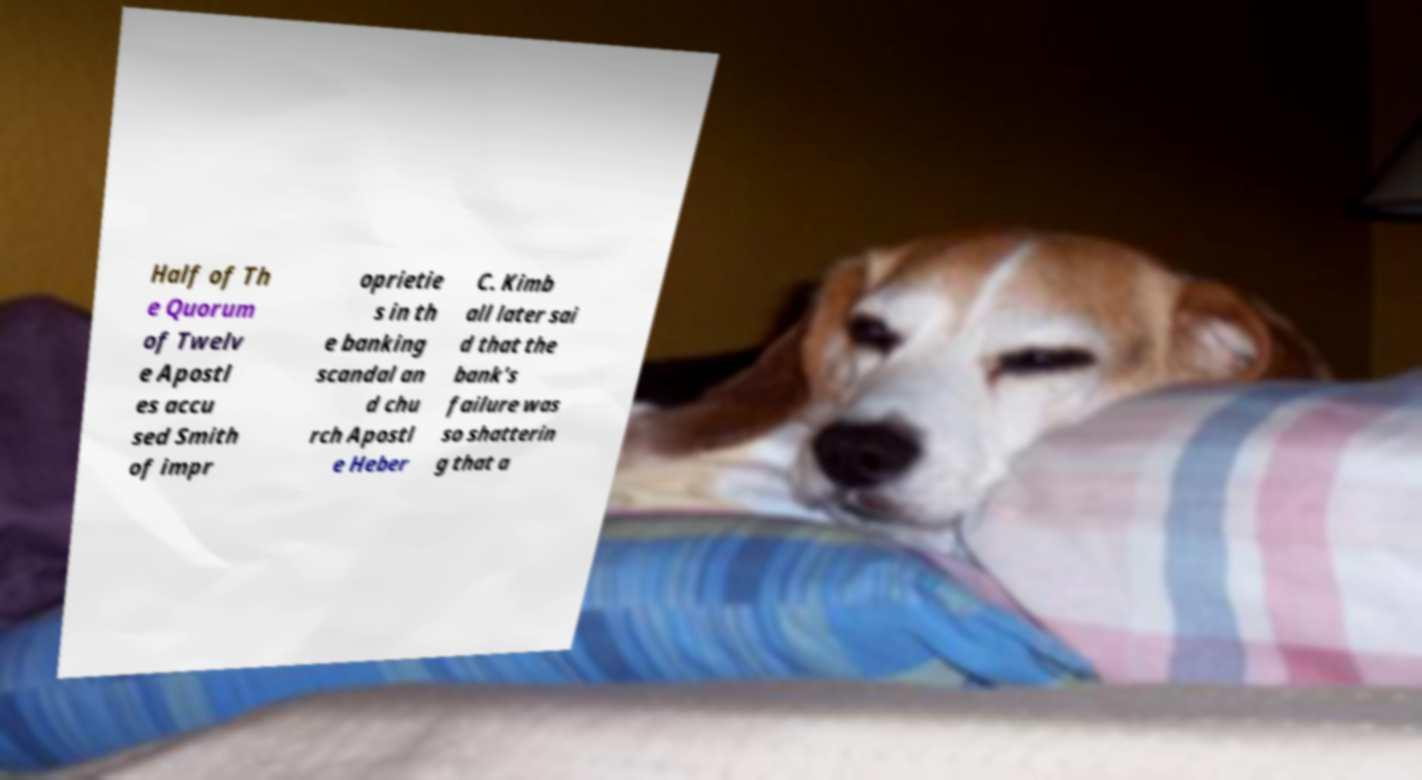Please identify and transcribe the text found in this image. Half of Th e Quorum of Twelv e Apostl es accu sed Smith of impr oprietie s in th e banking scandal an d chu rch Apostl e Heber C. Kimb all later sai d that the bank's failure was so shatterin g that a 